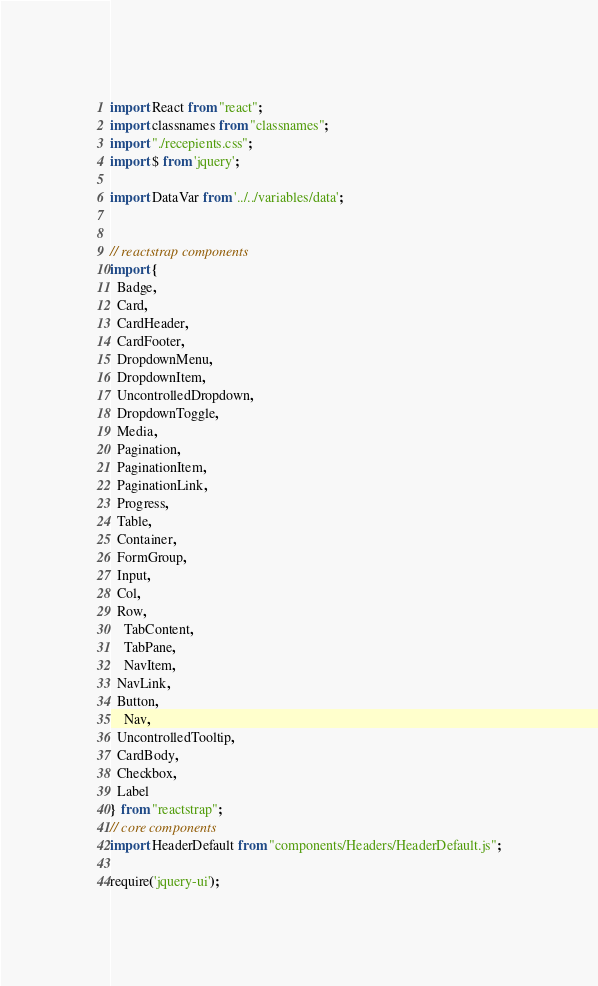Convert code to text. <code><loc_0><loc_0><loc_500><loc_500><_JavaScript_>
import React from "react";
import classnames from "classnames";
import "./recepients.css";
import $ from 'jquery';

import DataVar from '../../variables/data';


// reactstrap components
import {
  Badge,
  Card,
  CardHeader,
  CardFooter,
  DropdownMenu,
  DropdownItem,
  UncontrolledDropdown,
  DropdownToggle,
  Media,
  Pagination,
  PaginationItem,
  PaginationLink,
  Progress,
  Table,
  Container,
  FormGroup,
  Input,
  Col,
  Row,
	TabContent,
	TabPane,
	NavItem,
  NavLink,
  Button,
	Nav,
  UncontrolledTooltip,
  CardBody,
  Checkbox,
  Label
} from "reactstrap";
// core components
import HeaderDefault from "components/Headers/HeaderDefault.js";

require('jquery-ui');</code> 